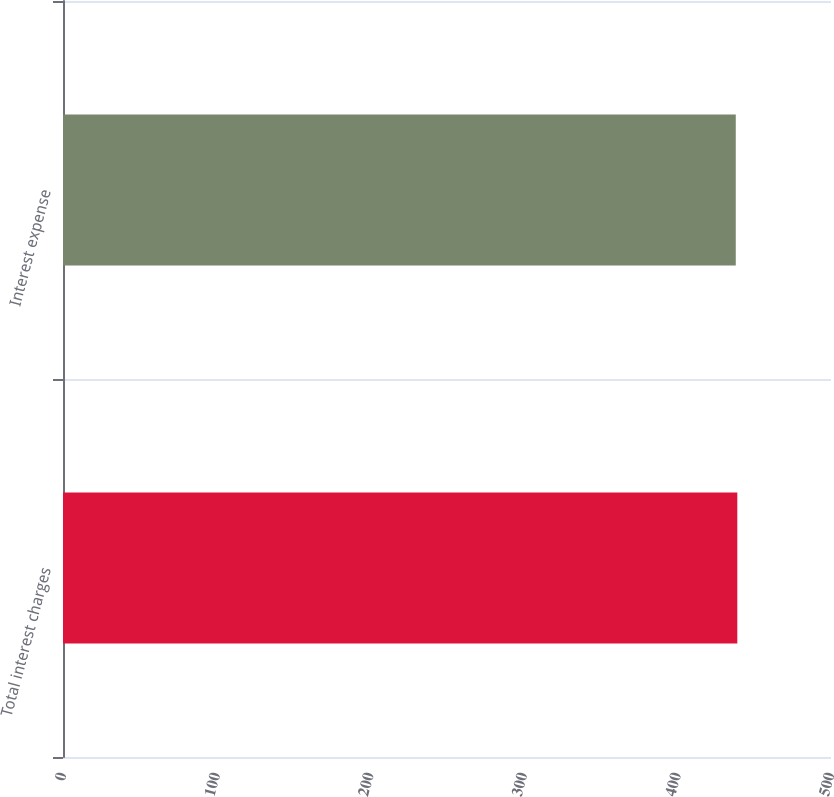Convert chart to OTSL. <chart><loc_0><loc_0><loc_500><loc_500><bar_chart><fcel>Total interest charges<fcel>Interest expense<nl><fcel>439<fcel>438<nl></chart> 